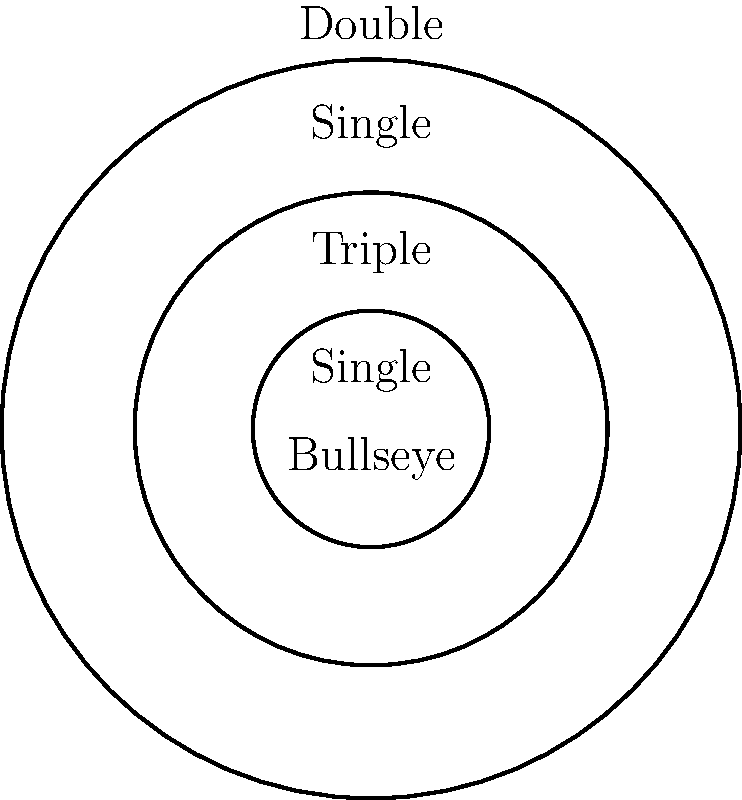In a standard dartboard, the outer ring (double) has a radius of 170 mm, and the inner bull (bullseye) has a radius of 12.7 mm. If the triple ring is positioned exactly halfway between the double ring and the bullseye, what percentage of the board's total area does the single scoring region occupy? Round your answer to the nearest whole number. Let's approach this step-by-step:

1) First, let's identify the radii:
   - Outer ring (double): $r_1 = 170$ mm
   - Inner bull (bullseye): $r_5 = 12.7$ mm
   - Triple ring: $r_3 = (170 + 12.7) / 2 = 91.35$ mm

2) We need to calculate the radius of the outer bull:
   - Outer bull: $r_4 = (91.35 + 12.7) / 2 = 52.025$ mm

3) Now we have all the radii:
   $r_1 = 170$ mm, $r_2 = 91.35$ mm, $r_3 = 91.35$ mm, $r_4 = 52.025$ mm, $r_5 = 12.7$ mm

4) The total area of the board is: $A_{total} = \pi r_1^2 = \pi (170)^2 = 90792.46$ sq mm

5) The single scoring region consists of two parts:
   - Outer single: $A_{outer} = \pi (r_1^2 - r_2^2) = \pi (170^2 - 91.35^2) = 64105.89$ sq mm
   - Inner single: $A_{inner} = \pi (r_3^2 - r_4^2) = \pi (91.35^2 - 52.025^2) = 16929.61$ sq mm

6) Total single area: $A_{single} = A_{outer} + A_{inner} = 64105.89 + 16929.61 = 81035.5$ sq mm

7) Percentage of single area:
   $\frac{A_{single}}{A_{total}} \times 100\% = \frac{81035.5}{90792.46} \times 100\% = 89.25\%$

8) Rounding to the nearest whole number: 89%
Answer: 89% 